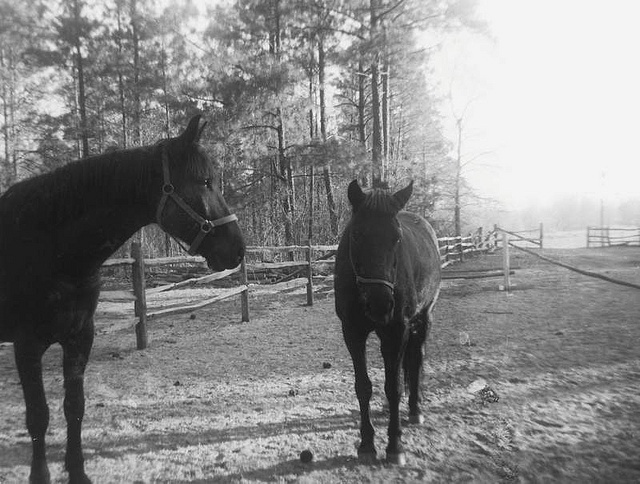Describe the objects in this image and their specific colors. I can see horse in darkgray, black, gray, and lightgray tones and horse in darkgray, black, gray, and lightgray tones in this image. 